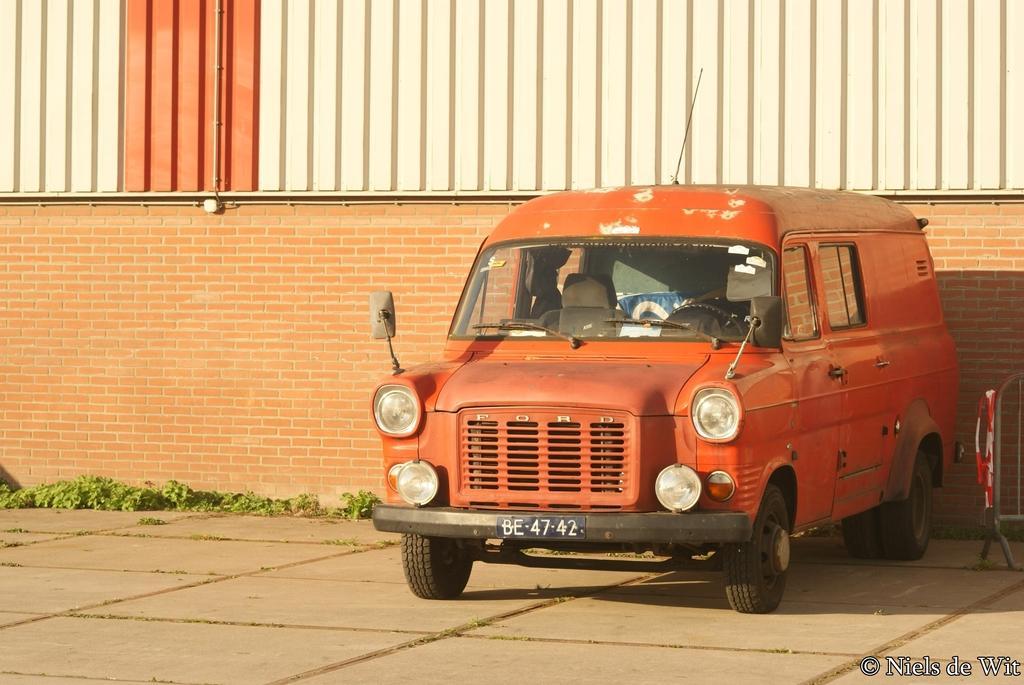Could you give a brief overview of what you see in this image? In this image I can see the ground, a vehicle which is orange in color on the ground and few plants. I can see a wall which is brown in color, a metal sheet which is cream and orange in color and few pipes. 